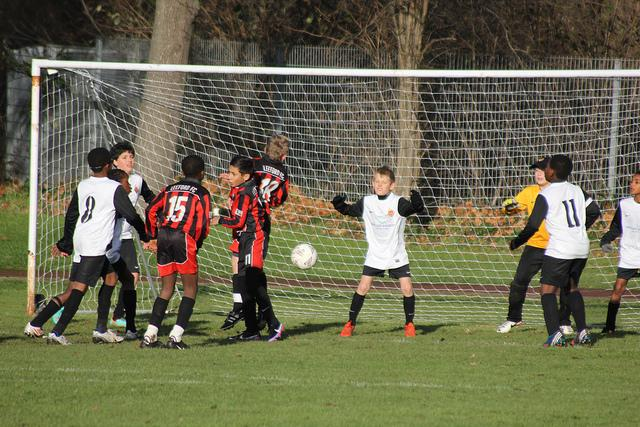Why is one kid wearing yellow? goalie 